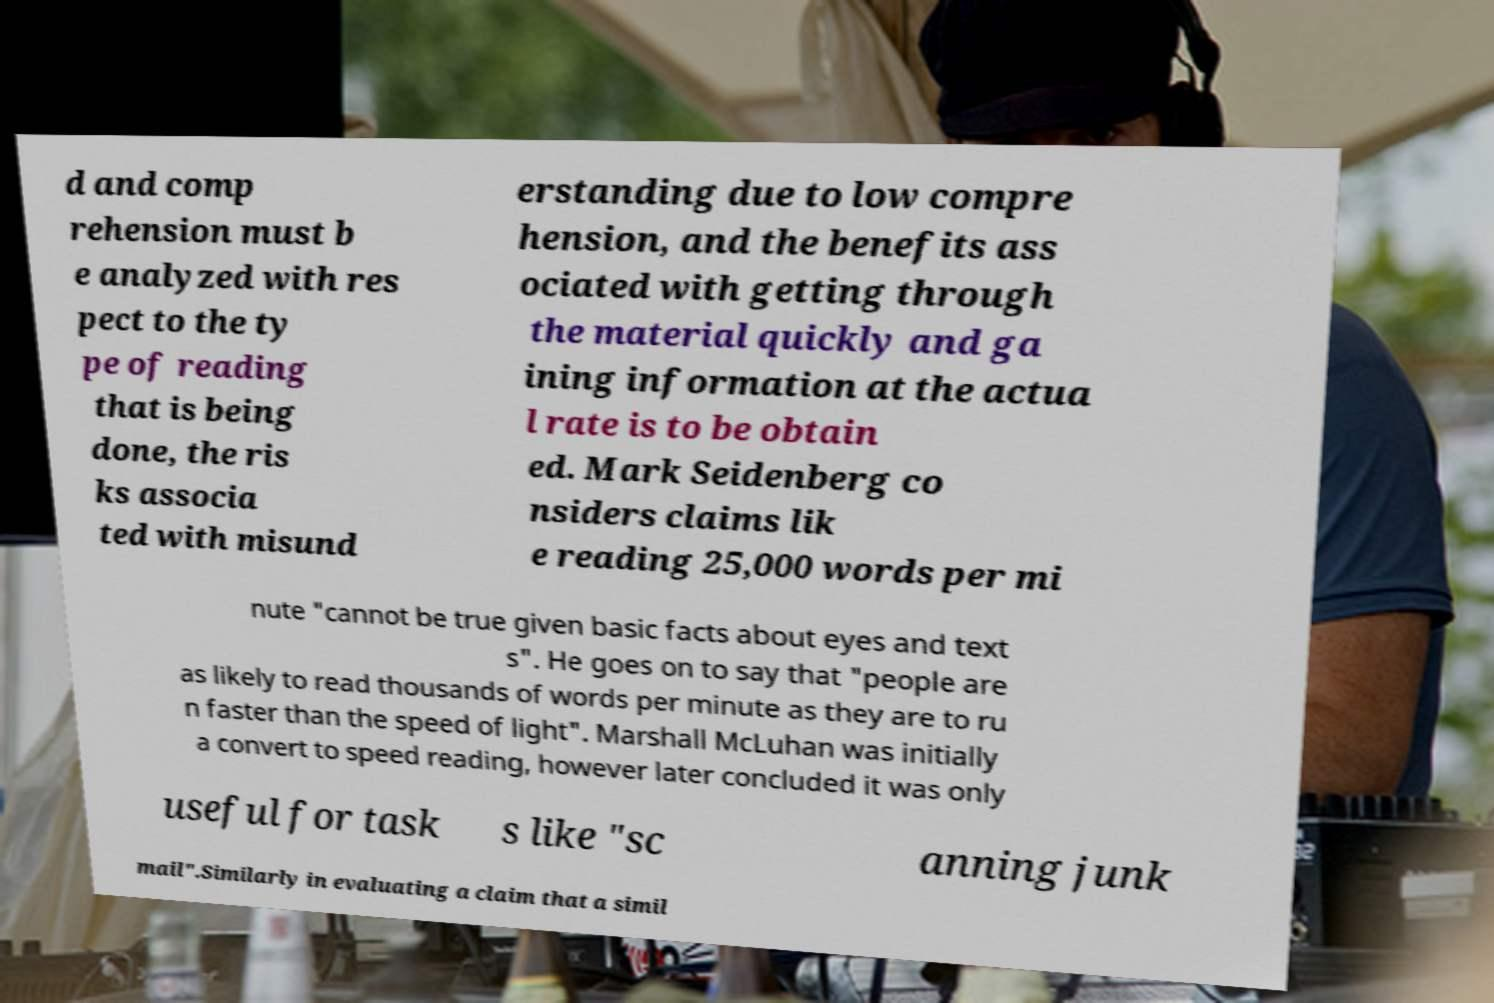Please identify and transcribe the text found in this image. d and comp rehension must b e analyzed with res pect to the ty pe of reading that is being done, the ris ks associa ted with misund erstanding due to low compre hension, and the benefits ass ociated with getting through the material quickly and ga ining information at the actua l rate is to be obtain ed. Mark Seidenberg co nsiders claims lik e reading 25,000 words per mi nute "cannot be true given basic facts about eyes and text s". He goes on to say that "people are as likely to read thousands of words per minute as they are to ru n faster than the speed of light". Marshall McLuhan was initially a convert to speed reading, however later concluded it was only useful for task s like "sc anning junk mail".Similarly in evaluating a claim that a simil 